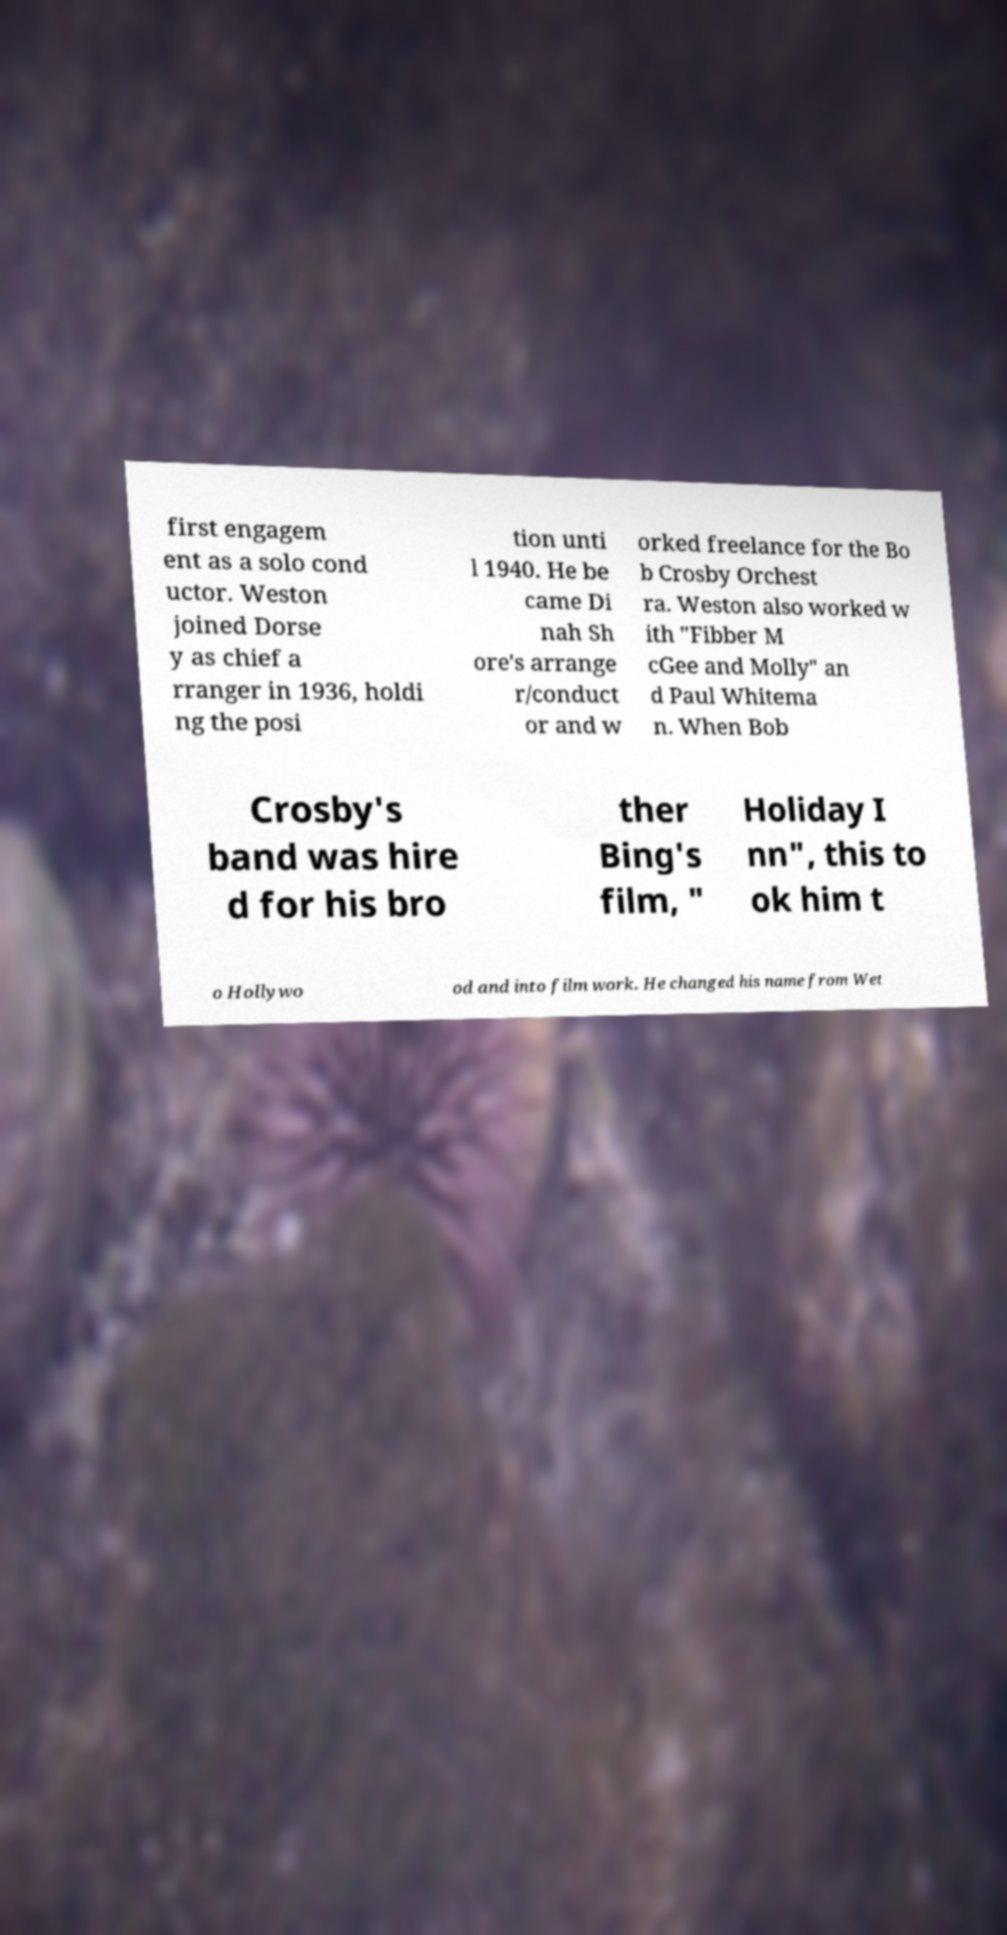Could you assist in decoding the text presented in this image and type it out clearly? first engagem ent as a solo cond uctor. Weston joined Dorse y as chief a rranger in 1936, holdi ng the posi tion unti l 1940. He be came Di nah Sh ore's arrange r/conduct or and w orked freelance for the Bo b Crosby Orchest ra. Weston also worked w ith "Fibber M cGee and Molly" an d Paul Whitema n. When Bob Crosby's band was hire d for his bro ther Bing's film, " Holiday I nn", this to ok him t o Hollywo od and into film work. He changed his name from Wet 